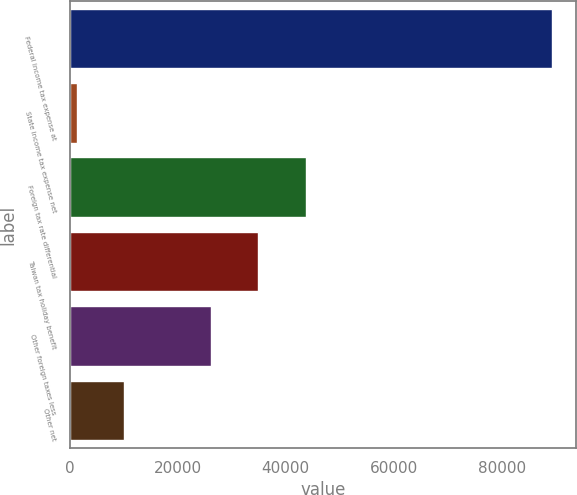Convert chart to OTSL. <chart><loc_0><loc_0><loc_500><loc_500><bar_chart><fcel>Federal income tax expense at<fcel>State income tax expense net<fcel>Foreign tax rate differential<fcel>Taiwan tax holiday benefit<fcel>Other foreign taxes less<fcel>Other net<nl><fcel>89324<fcel>1303<fcel>43684.2<fcel>34882.1<fcel>26080<fcel>10105.1<nl></chart> 